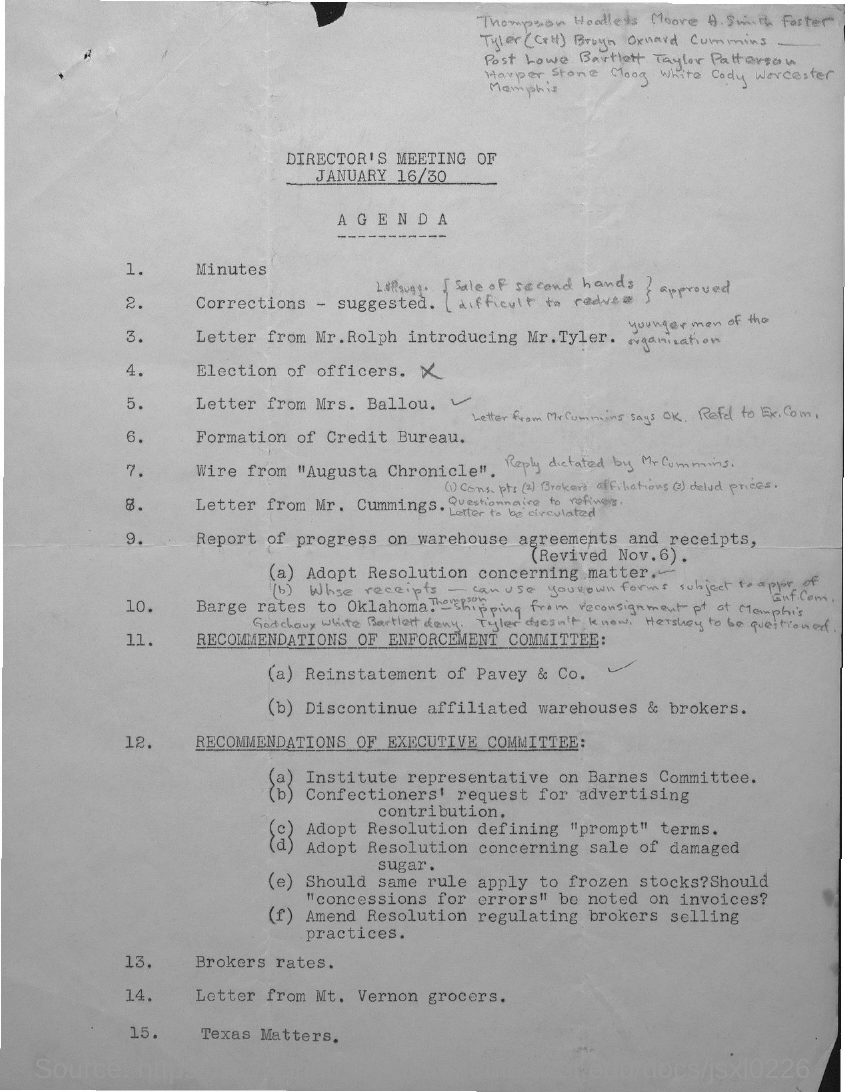What is the Agenda number 15?
Offer a very short reply. Texas Matters. What is the Agenda number 13?
Offer a terse response. Brokers rates. 